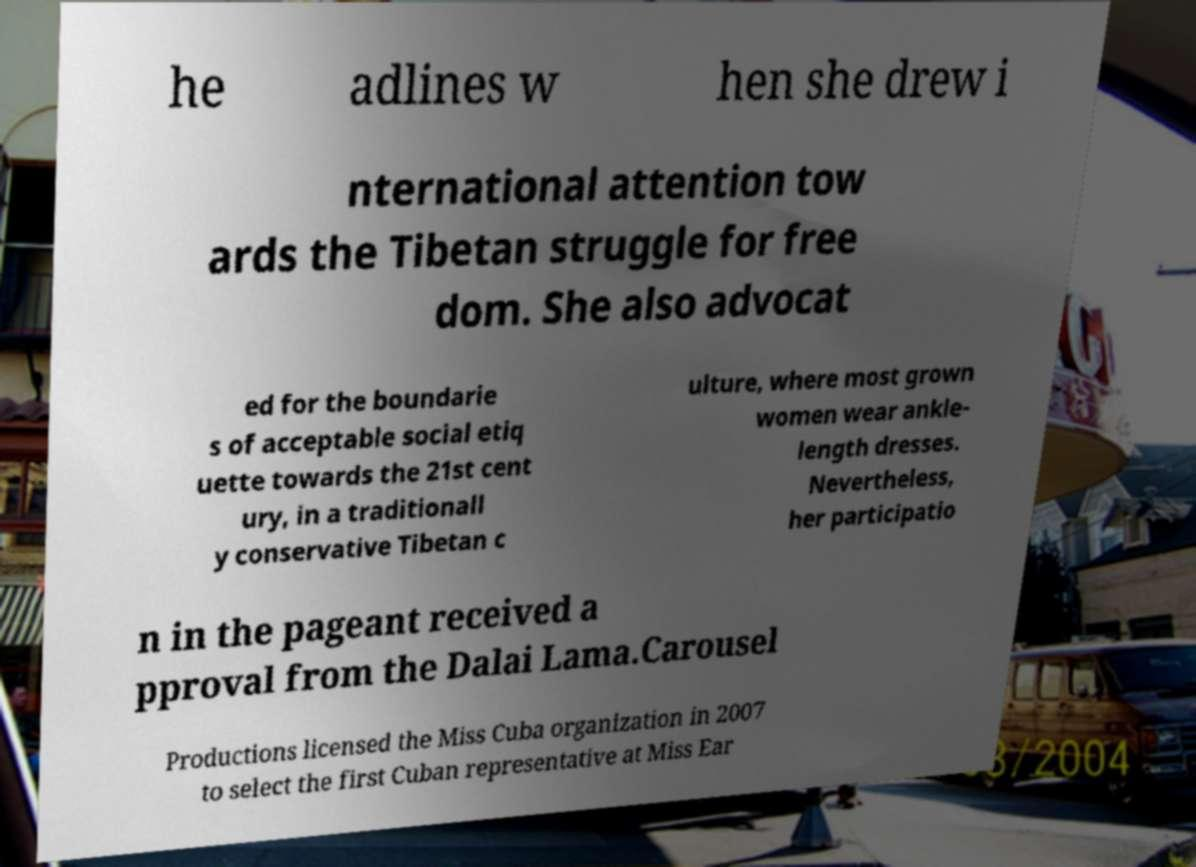Could you assist in decoding the text presented in this image and type it out clearly? he adlines w hen she drew i nternational attention tow ards the Tibetan struggle for free dom. She also advocat ed for the boundarie s of acceptable social etiq uette towards the 21st cent ury, in a traditionall y conservative Tibetan c ulture, where most grown women wear ankle- length dresses. Nevertheless, her participatio n in the pageant received a pproval from the Dalai Lama.Carousel Productions licensed the Miss Cuba organization in 2007 to select the first Cuban representative at Miss Ear 